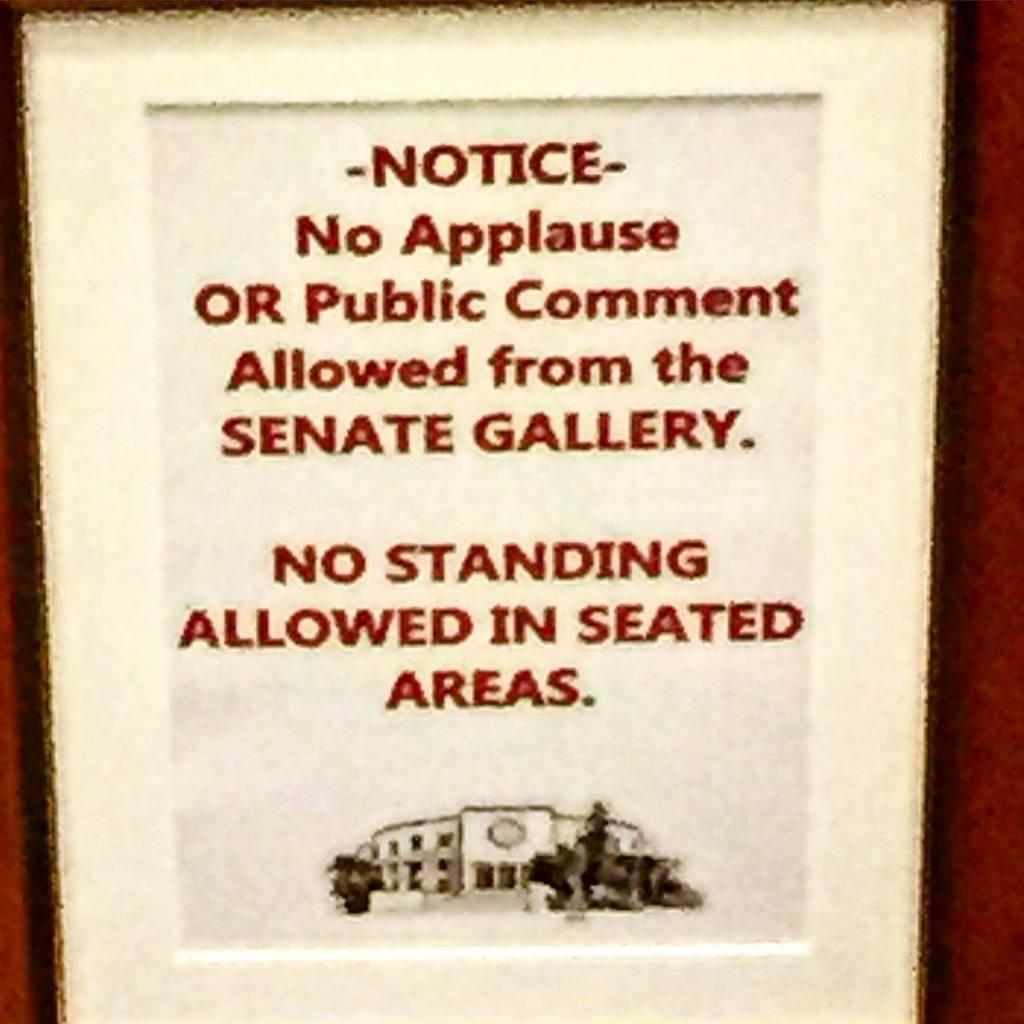Provide a one-sentence caption for the provided image. A poster displaying rules for the Senate Gallery. 